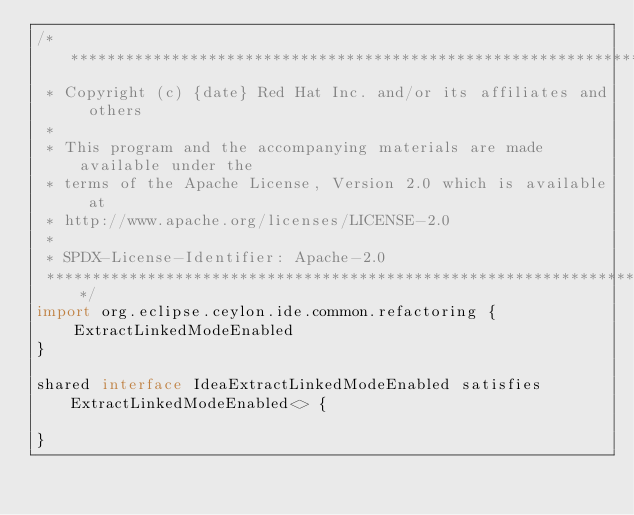<code> <loc_0><loc_0><loc_500><loc_500><_Ceylon_>/********************************************************************************
 * Copyright (c) {date} Red Hat Inc. and/or its affiliates and others
 *
 * This program and the accompanying materials are made available under the 
 * terms of the Apache License, Version 2.0 which is available at
 * http://www.apache.org/licenses/LICENSE-2.0
 *
 * SPDX-License-Identifier: Apache-2.0 
 ********************************************************************************/
import org.eclipse.ceylon.ide.common.refactoring {
    ExtractLinkedModeEnabled
}

shared interface IdeaExtractLinkedModeEnabled satisfies ExtractLinkedModeEnabled<> {
    
}</code> 